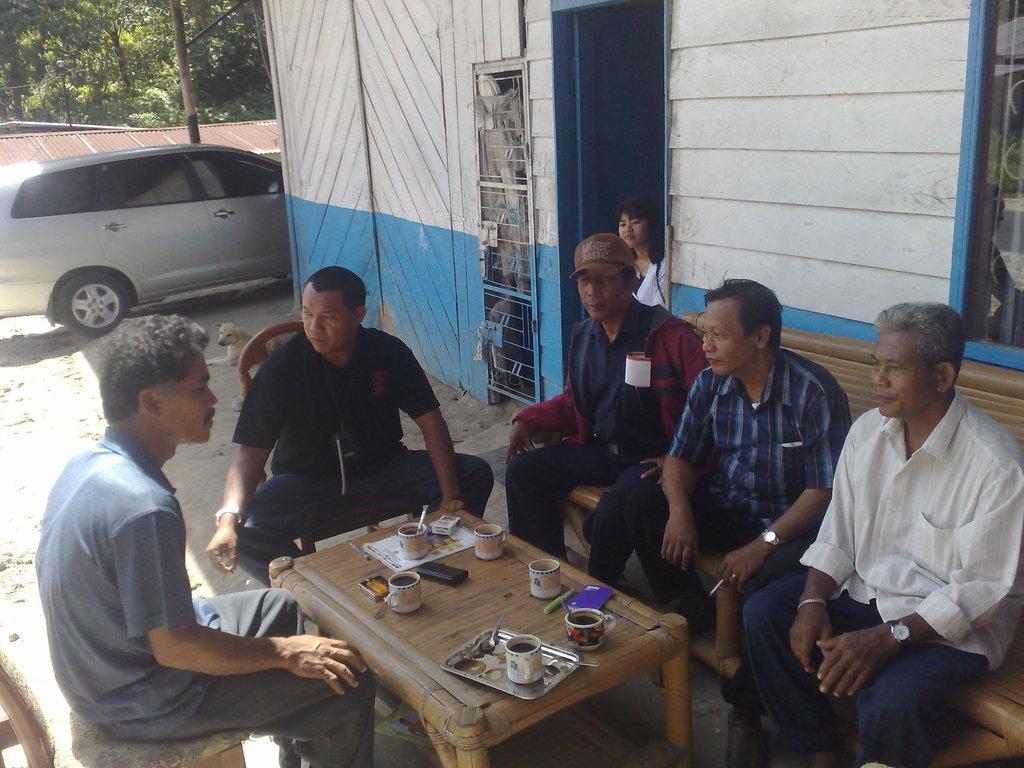How would you summarize this image in a sentence or two? The picture consists of few men sat on wooden chair and wooden sofa in front of them there is wooden table with coffee mug and tray on it. Over to the right side there is a home with lady at the entrance and left side there is a car. 